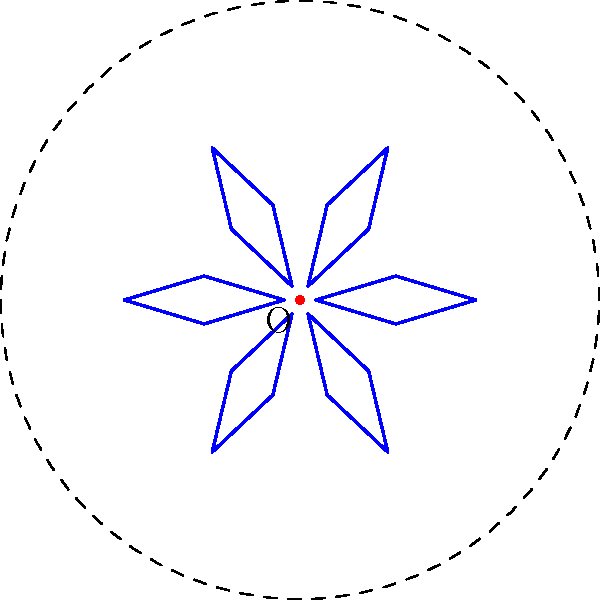A surfboard designer wants to create a circular pattern using a single surfboard design. The pattern is formed by rotating the surfboard around a fixed point O. If the pattern completes a full circle with 6 equally spaced surfboards, what is the angle of rotation between each surfboard? To solve this problem, let's follow these steps:

1. Understand the given information:
   - The pattern forms a complete circle.
   - There are 6 equally spaced surfboards in the pattern.

2. Recall that a full circle contains 360°.

3. To find the angle between each surfboard, we need to divide the total angle of the circle by the number of surfboards:

   $$ \text{Angle of rotation} = \frac{\text{Total angle of circle}}{\text{Number of surfboards}} $$

4. Substituting the values:

   $$ \text{Angle of rotation} = \frac{360°}{6} = 60° $$

Therefore, the angle of rotation between each surfboard in the pattern is 60°.
Answer: 60° 